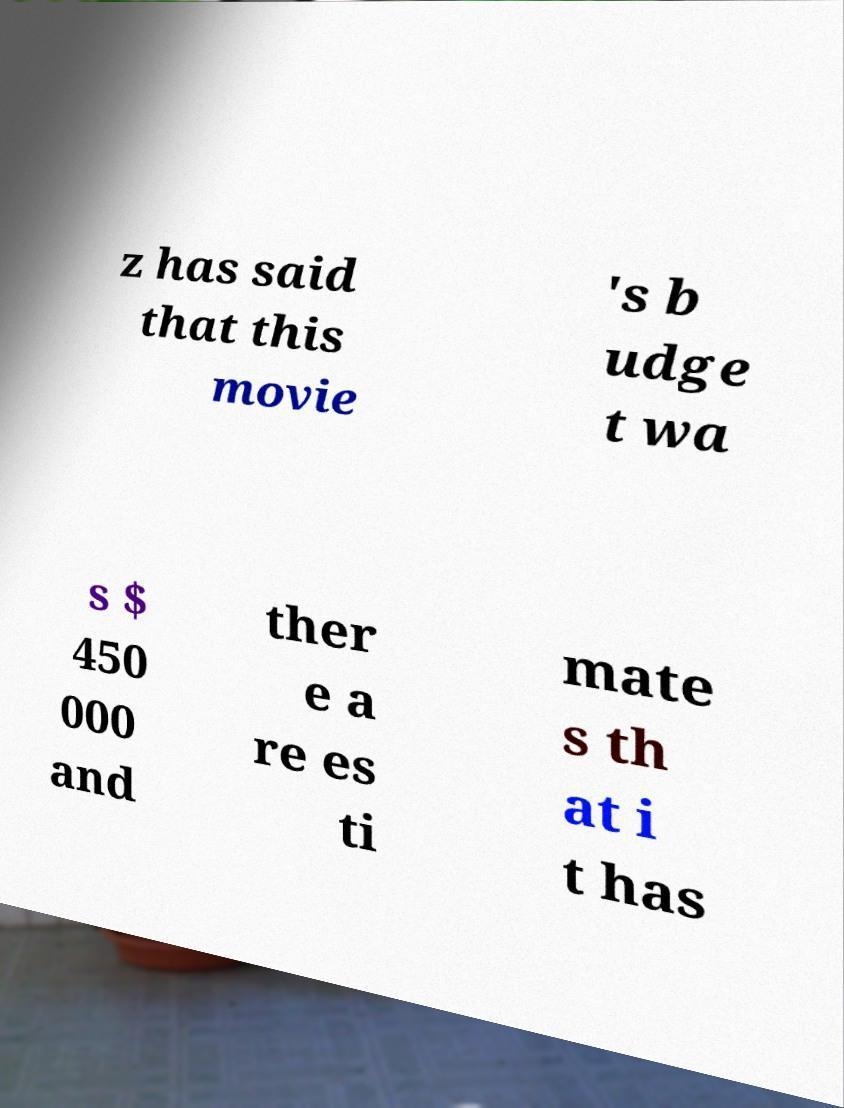Please identify and transcribe the text found in this image. z has said that this movie 's b udge t wa s $ 450 000 and ther e a re es ti mate s th at i t has 